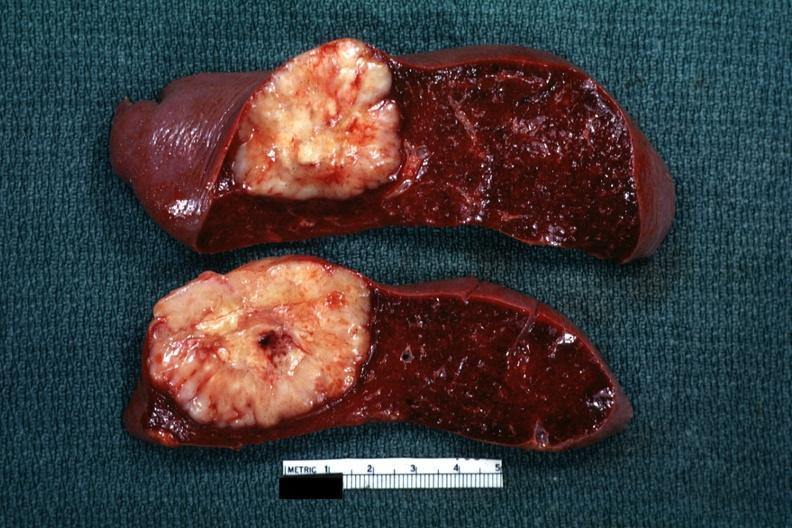what is single metastatic appearing lesion was reticulum cell sarcoma?
Answer the question using a single word or phrase. Quite large diagnosis 